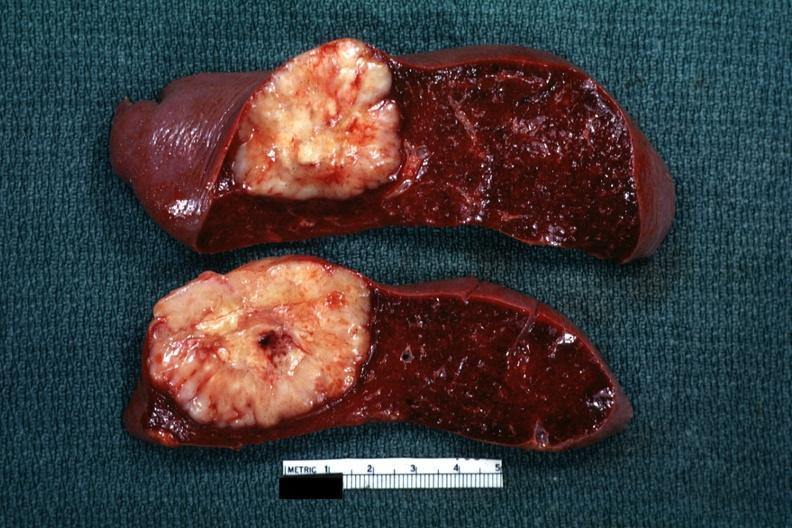what is single metastatic appearing lesion was reticulum cell sarcoma?
Answer the question using a single word or phrase. Quite large diagnosis 